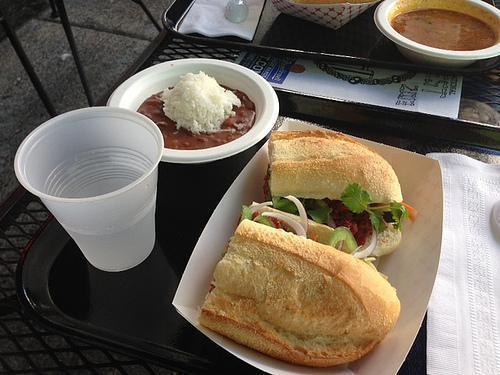How many sandwich halves are there?
Give a very brief answer. 2. 